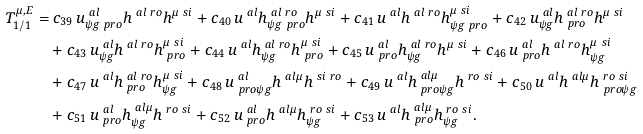<formula> <loc_0><loc_0><loc_500><loc_500>T _ { 1 / 1 } ^ { \mu , E } = & \ c _ { 3 9 } \, u ^ { \ a l } _ { \psi g \ p r o } h ^ { \ a l \ r o } h ^ { \mu \ s i } + c _ { 4 0 } \, u ^ { \ a l } h ^ { \ a l \ r o } _ { \psi g \ p r o } h ^ { \mu \ s i } + c _ { 4 1 } \, u ^ { \ a l } h ^ { \ a l \ r o } h ^ { \mu \ s i } _ { \psi g \ p r o } + c _ { 4 2 } \, u ^ { \ a l } _ { \psi g } h ^ { \ a l \ r o } _ { \ p r o } h ^ { \mu \ s i } \\ & + c _ { 4 3 } \, u ^ { \ a l } _ { \psi g } h ^ { \ a l \ r o } h ^ { \mu \ s i } _ { \ p r o } + c _ { 4 4 } \, u ^ { \ a l } h ^ { \ a l \ r o } _ { \psi g } h ^ { \mu \ s i } _ { \ p r o } + c _ { 4 5 } \, u ^ { \ a l } _ { \ p r o } h ^ { \ a l \ r o } _ { \psi g } h ^ { \mu \ s i } + c _ { 4 6 } \, u ^ { \ a l } _ { \ p r o } h ^ { \ a l \ r o } h ^ { \mu \ s i } _ { \psi g } \\ & + c _ { 4 7 } \, u ^ { \ a l } h ^ { \ a l \ r o } _ { \ p r o } h ^ { \mu \ s i } _ { \psi g } + c _ { 4 8 } \, u ^ { \ a l } _ { \ p r o \psi g } h ^ { \ a l \mu } h ^ { \ s i \ r o } + c _ { 4 9 } \, u ^ { \ a l } h ^ { \ a l \mu } _ { \ p r o \psi g } h ^ { \ r o \ s i } + c _ { 5 0 } \, u ^ { \ a l } h ^ { \ a l \mu } h ^ { \ r o \ s i } _ { \ p r o \psi g } \\ & + c _ { 5 1 } \, u ^ { \ a l } _ { \ p r o } h ^ { \ a l \mu } _ { \psi g } h ^ { \ r o \ s i } + c _ { 5 2 } \, u ^ { \ a l } _ { \ p r o } h ^ { \ a l \mu } h ^ { \ r o \ s i } _ { \psi g } + c _ { 5 3 } \, u ^ { \ a l } h ^ { \ a l \mu } _ { \ p r o } h ^ { \ r o \ s i } _ { \psi g } . \\</formula> 